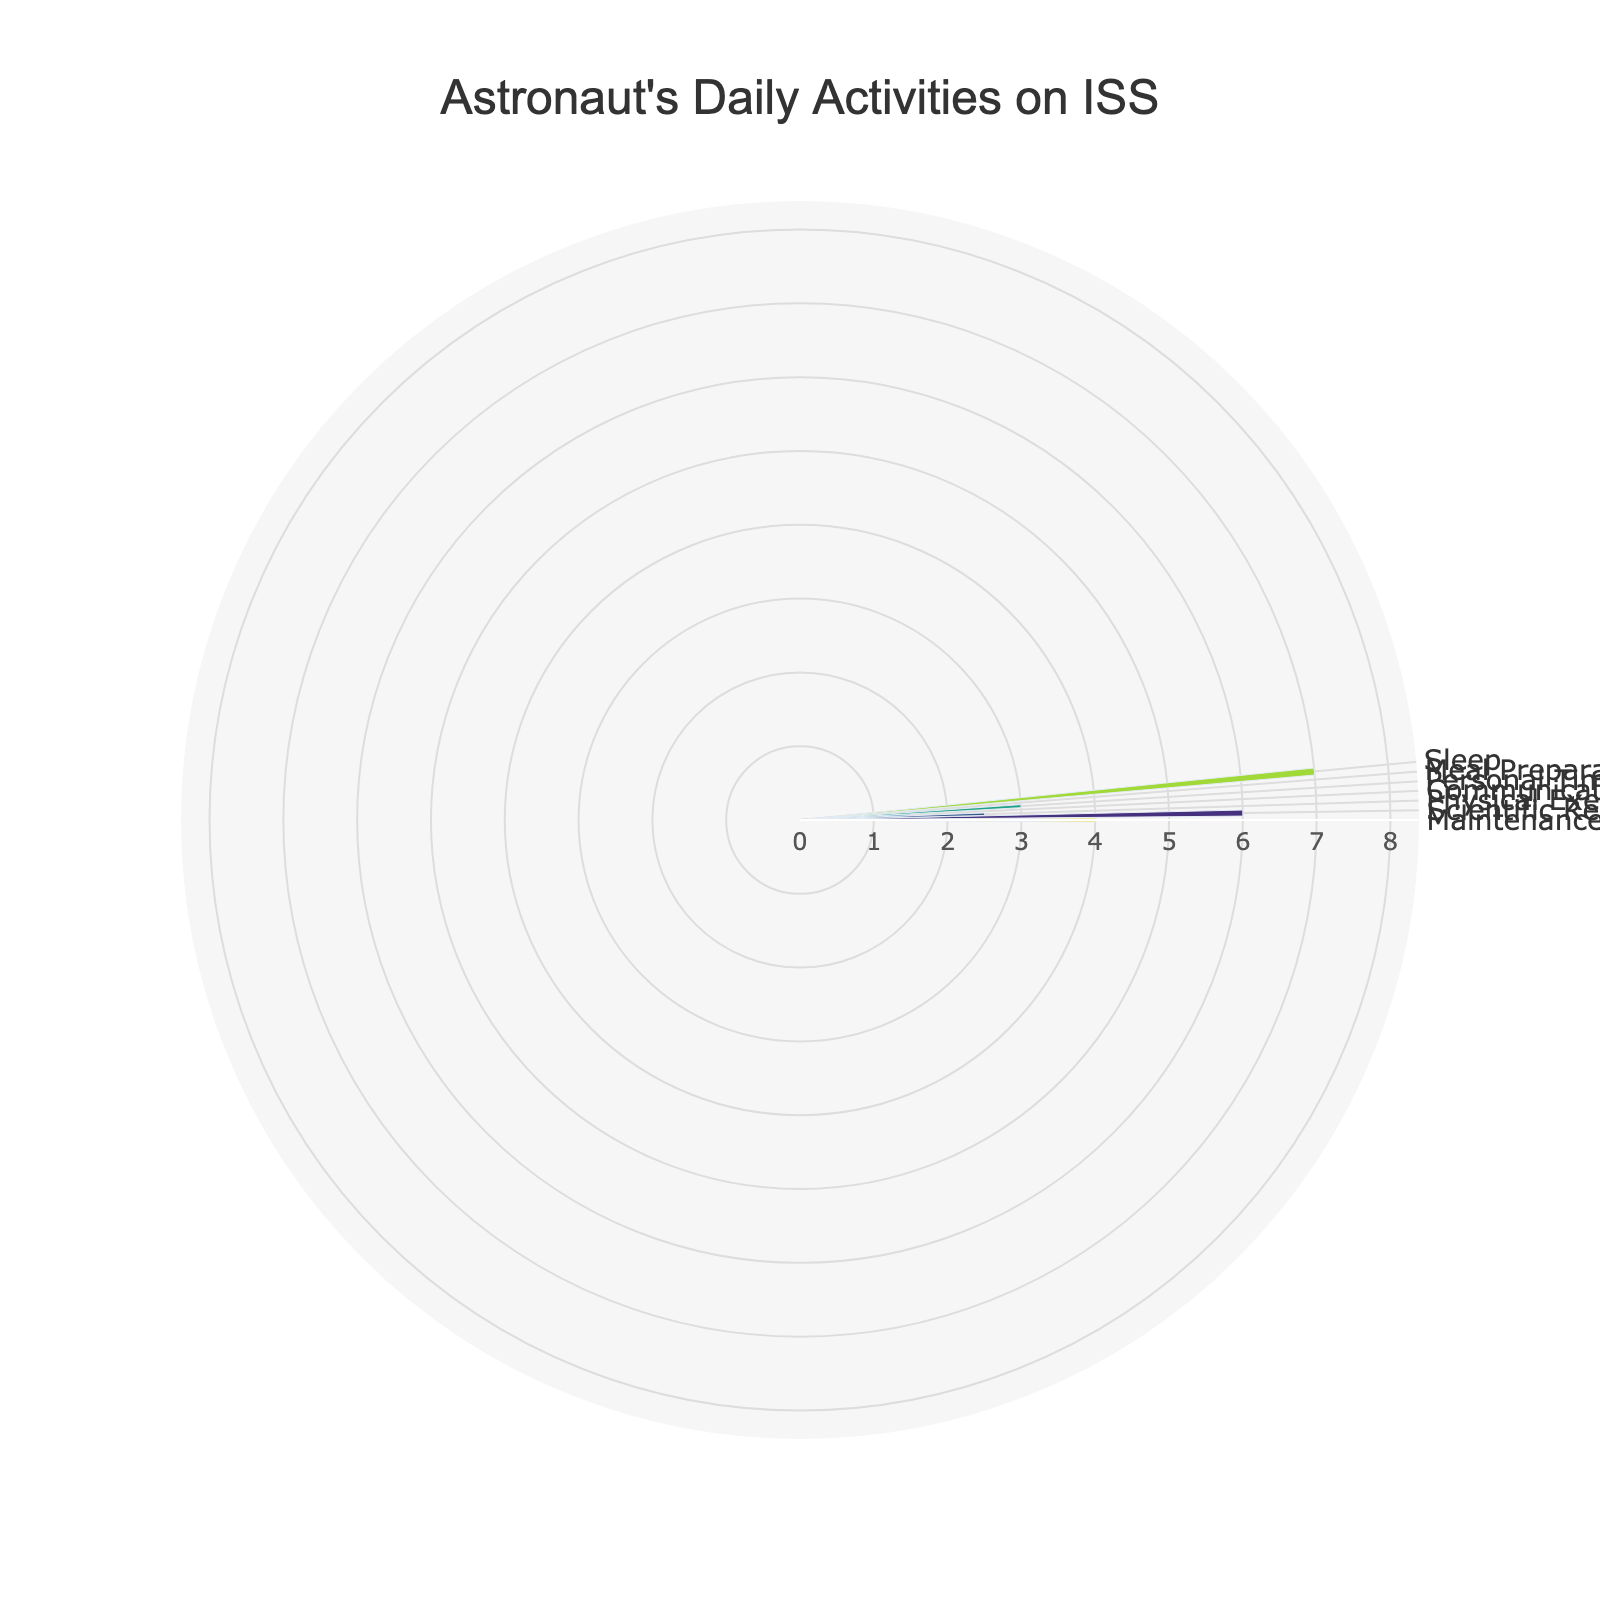What is the title of the chart? The title is at the top of the chart and prominently displayed in the layout. It reads "Astronaut's Daily Activities on ISS."
Answer: Astronaut's Daily Activities on ISS Which activity occupies the most hours of the astronaut's day? By examining the chart, observe the length of the bars. The longest bar represents "Scientific Research," which occupies 6 hours.
Answer: Scientific Research What proportion of the day is spent on physical exercise? The total day is 24 hours, and the time spent on Physical Exercise is 2.5 hours. Calculate the proportion as (2.5/24).
Answer: Approximately 10.42% How much more time is spent on scientific research compared to meal preparation and eating combined? Scientific Research takes 6 hours, and Meal Preparation/Eating takes 1 hour. The difference is calculated as 6 - 1.
Answer: 5 hours What activities occupy exactly 2 hours each? Observe the lengths of the bars marked with 2 hours. Maintenance activities take up exactly 2 hours.
Answer: Maintenance Which activity is least time-consuming? The bar representing the smallest number of hours will show the least time-consuming activity. Meal Preparation/Eating, with 1 hour, is the least.
Answer: Meal Preparation/Eating How do personal time and sleep compare in terms of hours spent? Personal Time is 3 hours, and Sleep is 7 hours. Comparing these, Sleep takes 4 hours more than Personal Time.
Answer: Sleep is 4 hours more What is the total number of hours for Communication and Maintenance combined? Add the hours for Communication (1.5 hours) and Maintenance (2 hours). The total is 1.5 + 2.
Answer: 3.5 hours Which activities consume more than 2 hours but less than 6 hours? Observing the lengths of the bars, Physical Exercise (2.5 hours), Sleep (7 hours), and Communication (1.5 hours) meet the criteria.
Answer: Physical Exercise, Personal Time What percentage of the day does the astronaut spend on sleep? The total day is 24 hours, and Sleep occupies 7 hours. Calculate the percentage as (7/24) * 100.
Answer: Approximately 29.17% 